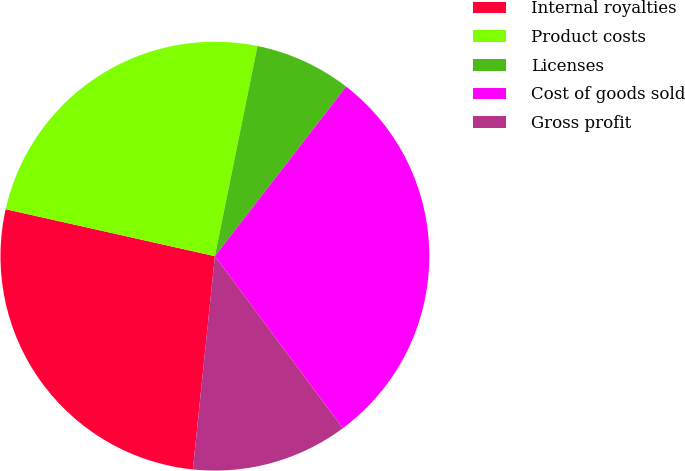Convert chart to OTSL. <chart><loc_0><loc_0><loc_500><loc_500><pie_chart><fcel>Internal royalties<fcel>Product costs<fcel>Licenses<fcel>Cost of goods sold<fcel>Gross profit<nl><fcel>26.88%<fcel>24.67%<fcel>7.3%<fcel>29.35%<fcel>11.81%<nl></chart> 